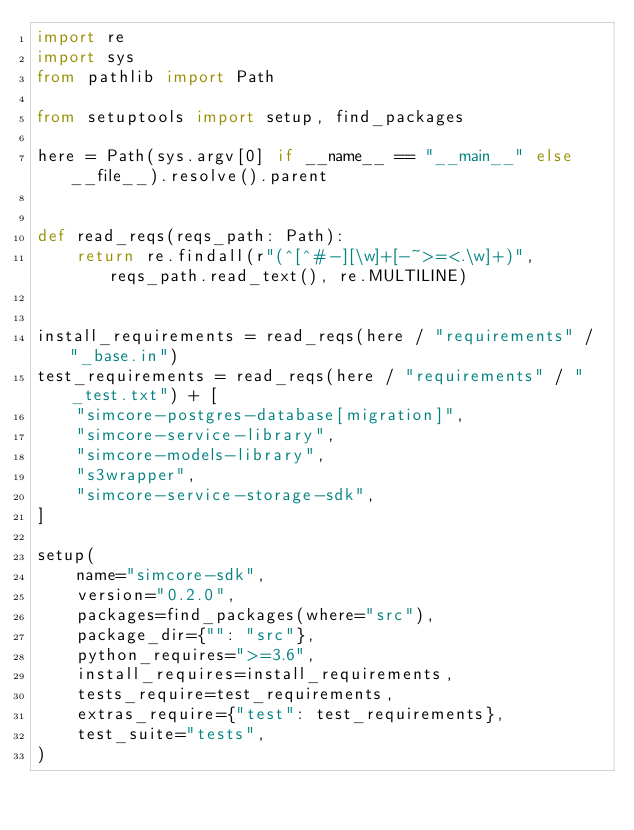Convert code to text. <code><loc_0><loc_0><loc_500><loc_500><_Python_>import re
import sys
from pathlib import Path

from setuptools import setup, find_packages

here = Path(sys.argv[0] if __name__ == "__main__" else __file__).resolve().parent


def read_reqs(reqs_path: Path):
    return re.findall(r"(^[^#-][\w]+[-~>=<.\w]+)", reqs_path.read_text(), re.MULTILINE)


install_requirements = read_reqs(here / "requirements" / "_base.in")
test_requirements = read_reqs(here / "requirements" / "_test.txt") + [
    "simcore-postgres-database[migration]",
    "simcore-service-library",
    "simcore-models-library",
    "s3wrapper",
    "simcore-service-storage-sdk",
]

setup(
    name="simcore-sdk",
    version="0.2.0",
    packages=find_packages(where="src"),
    package_dir={"": "src"},
    python_requires=">=3.6",
    install_requires=install_requirements,
    tests_require=test_requirements,
    extras_require={"test": test_requirements},
    test_suite="tests",
)
</code> 